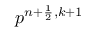Convert formula to latex. <formula><loc_0><loc_0><loc_500><loc_500>p ^ { n + \frac { 1 } { 2 } , k + 1 }</formula> 